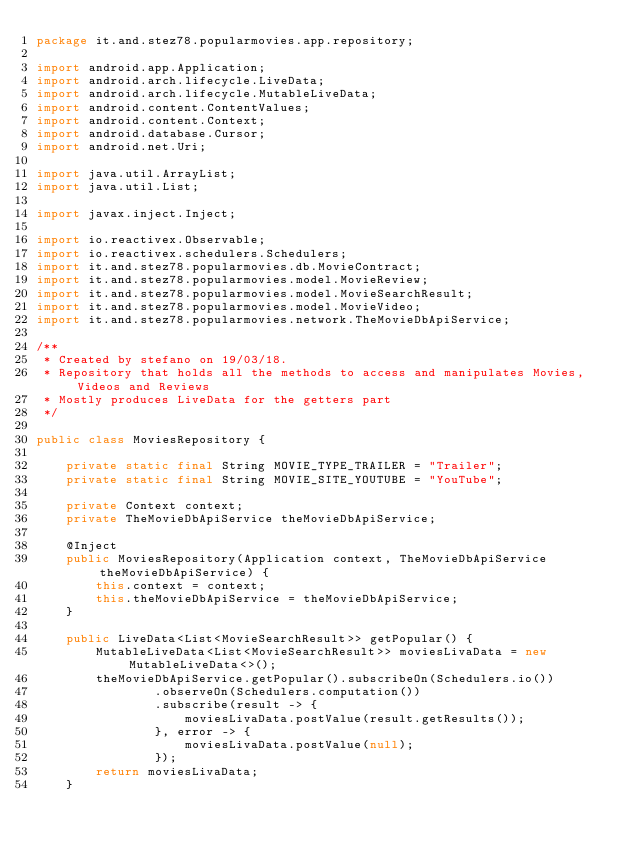Convert code to text. <code><loc_0><loc_0><loc_500><loc_500><_Java_>package it.and.stez78.popularmovies.app.repository;

import android.app.Application;
import android.arch.lifecycle.LiveData;
import android.arch.lifecycle.MutableLiveData;
import android.content.ContentValues;
import android.content.Context;
import android.database.Cursor;
import android.net.Uri;

import java.util.ArrayList;
import java.util.List;

import javax.inject.Inject;

import io.reactivex.Observable;
import io.reactivex.schedulers.Schedulers;
import it.and.stez78.popularmovies.db.MovieContract;
import it.and.stez78.popularmovies.model.MovieReview;
import it.and.stez78.popularmovies.model.MovieSearchResult;
import it.and.stez78.popularmovies.model.MovieVideo;
import it.and.stez78.popularmovies.network.TheMovieDbApiService;

/**
 * Created by stefano on 19/03/18.
 * Repository that holds all the methods to access and manipulates Movies, Videos and Reviews
 * Mostly produces LiveData for the getters part
 */

public class MoviesRepository {

    private static final String MOVIE_TYPE_TRAILER = "Trailer";
    private static final String MOVIE_SITE_YOUTUBE = "YouTube";

    private Context context;
    private TheMovieDbApiService theMovieDbApiService;

    @Inject
    public MoviesRepository(Application context, TheMovieDbApiService theMovieDbApiService) {
        this.context = context;
        this.theMovieDbApiService = theMovieDbApiService;
    }

    public LiveData<List<MovieSearchResult>> getPopular() {
        MutableLiveData<List<MovieSearchResult>> moviesLivaData = new MutableLiveData<>();
        theMovieDbApiService.getPopular().subscribeOn(Schedulers.io())
                .observeOn(Schedulers.computation())
                .subscribe(result -> {
                    moviesLivaData.postValue(result.getResults());
                }, error -> {
                    moviesLivaData.postValue(null);
                });
        return moviesLivaData;
    }
</code> 